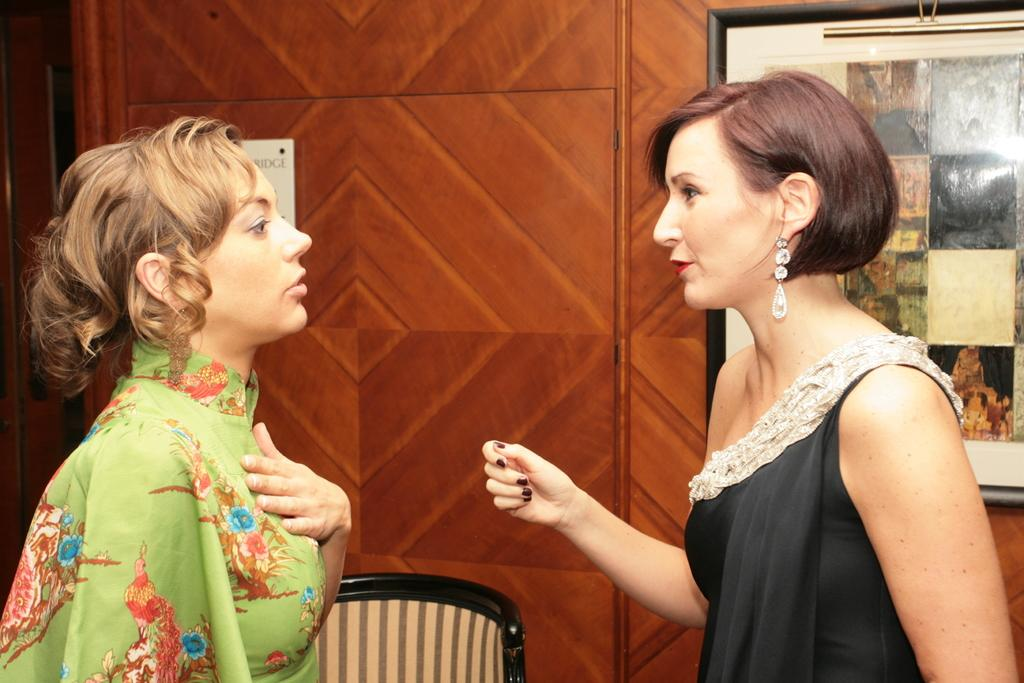What are the women in the image doing? The women in the image are standing and speaking to each other. What can be seen on the wall in the image? There is a photo frame on the wall in the image. What type of furniture is present in the image? There is a chair in the image. What is written or displayed on the board in the image? There is a board with text in the image. What type of quince is being served on the table in the image? There is no table or quince present in the image; it features women standing and speaking to each other, a photo frame on the wall, a chair, and a board with text. How many men are visible in the image? There are no men visible in the image; it features women standing and speaking to each other, a photo frame on the wall, a chair, and a board with text. 